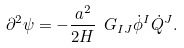<formula> <loc_0><loc_0><loc_500><loc_500>\partial ^ { 2 } \psi = - \frac { a ^ { 2 } } { 2 H } \ G _ { I J } \dot { \phi } ^ { I } \dot { Q } ^ { J } .</formula> 